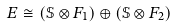Convert formula to latex. <formula><loc_0><loc_0><loc_500><loc_500>E \cong \left ( \mathbb { S } \otimes F _ { 1 } \right ) \oplus \left ( \mathbb { S } \otimes F _ { 2 } \right )</formula> 